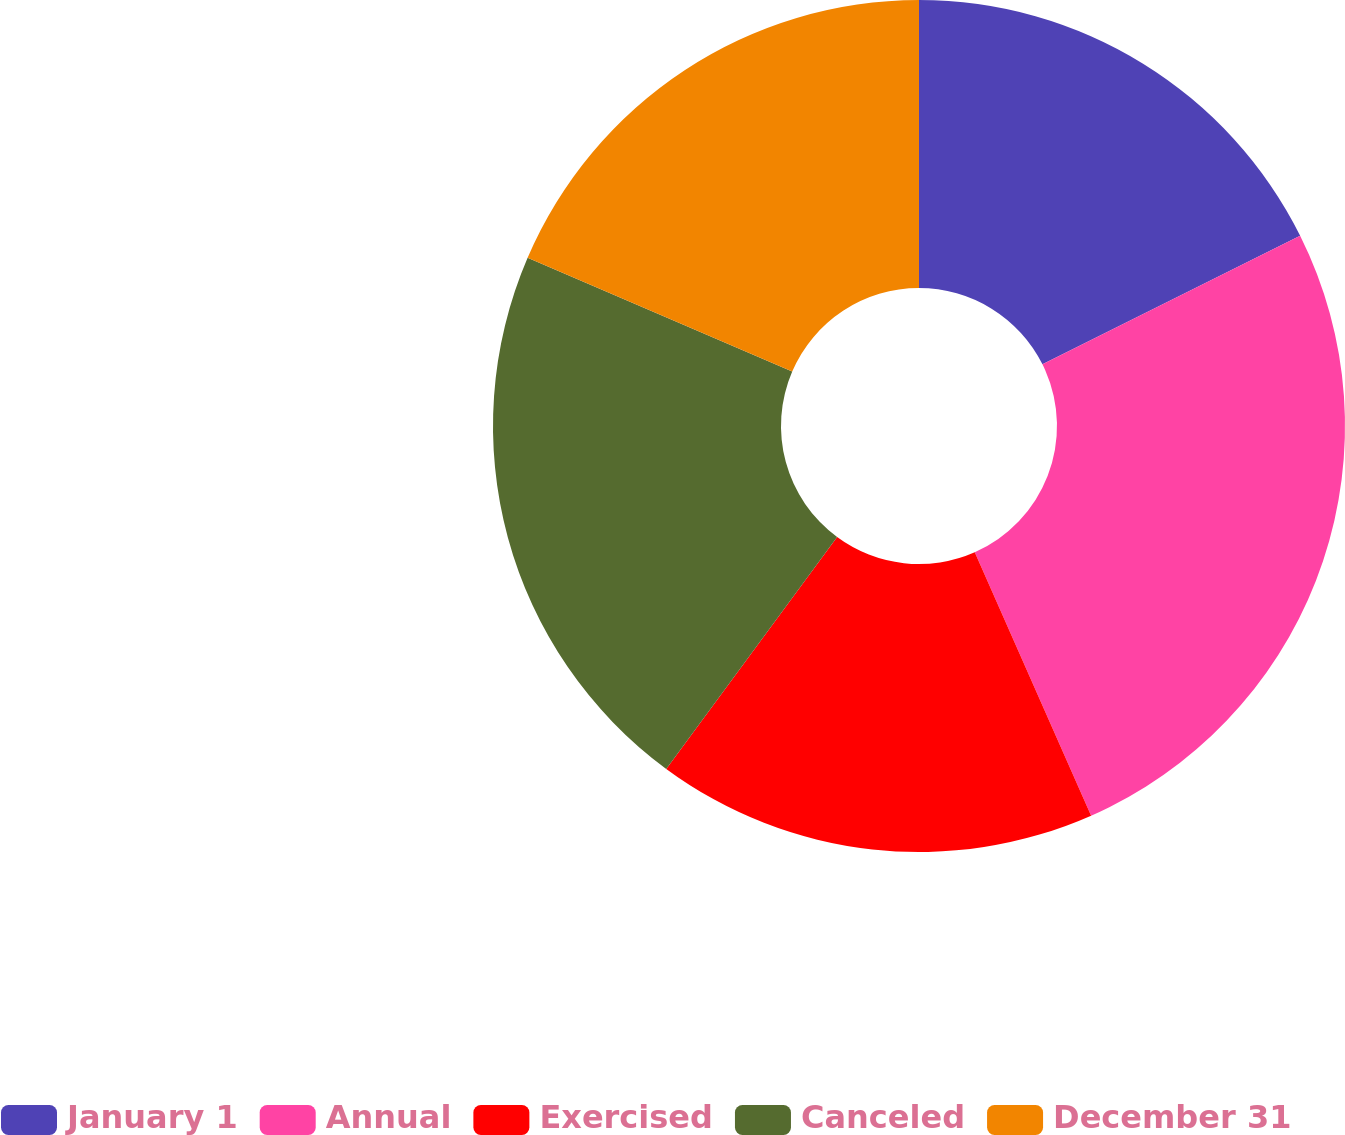<chart> <loc_0><loc_0><loc_500><loc_500><pie_chart><fcel>January 1<fcel>Annual<fcel>Exercised<fcel>Canceled<fcel>December 31<nl><fcel>17.63%<fcel>25.75%<fcel>16.73%<fcel>21.35%<fcel>18.54%<nl></chart> 